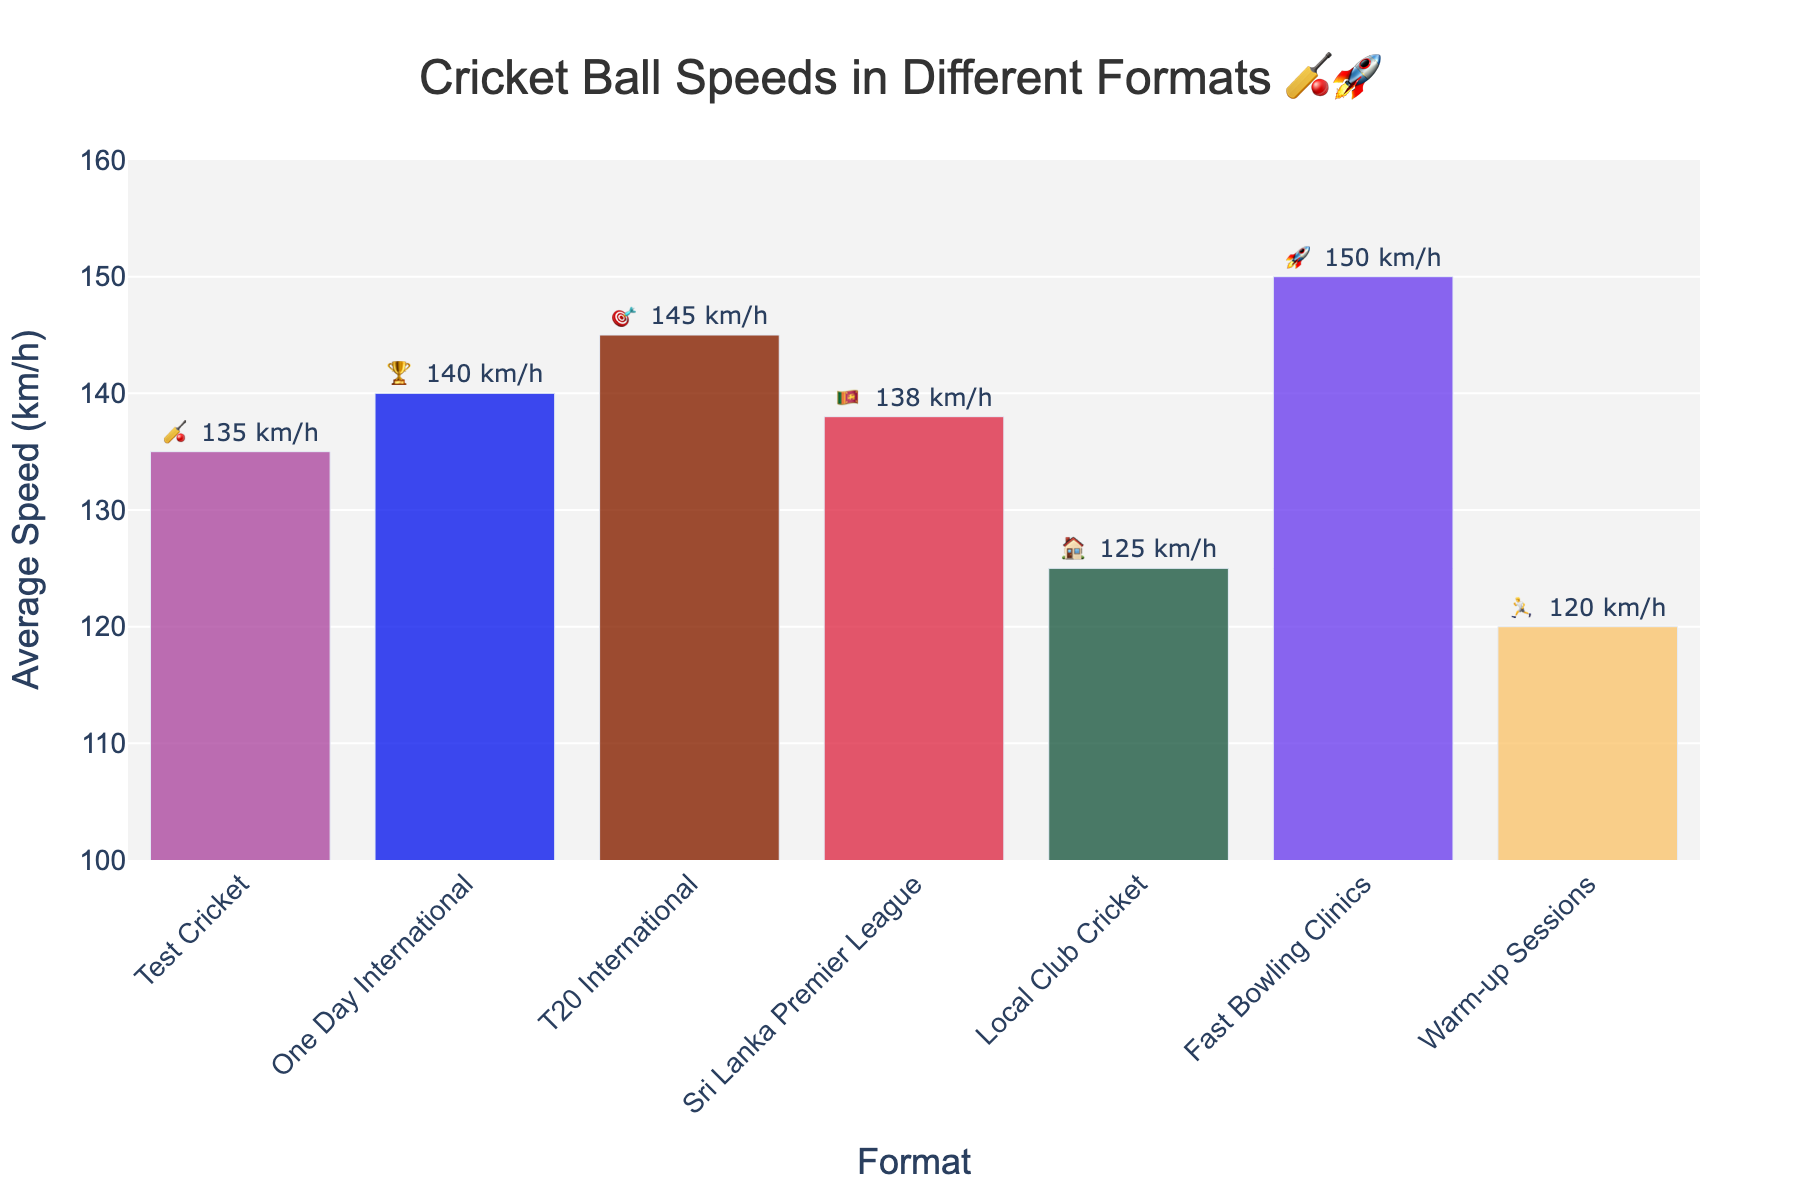what is the title of the figure? The title is found at the top of the figure and is designed to give a quick summary of the content of the chart.
Answer: Cricket Ball Speeds in Different Formats 🏏🚀 which format has the highest average speed? Look for the highest bar in the figure, as the bar's height corresponds to the speed.
Answer: Fast Bowling Clinics what is the average speed for T20 International? Identify the bar labeled T20 International and read its corresponding value.
Answer: 145 km/h how much faster is Sri Lanka Premier League compared to Local Club Cricket? Subtract the speed of Local Club Cricket from that of the Sri Lanka Premier League.
Answer: 13 km/h which format has the lowest average speed, and what is that speed? Identify the shortest bar in the figure and note its label and height.
Answer: Warm-up Sessions, 120 km/h how many formats have an average speed greater than 140 km/h? Count the number of bars that have values higher than 140 km/h.
Answer: 2 what is the difference in average speed between One Day International and Test Cricket? Subtract the speed of Test Cricket from that of One Day International.
Answer: 5 km/h are there more formats with speeds above or below 130 km/h? Count the number of bars above and below 130 km/h and compare.
Answer: More above 130 km/h in which formats is the average speed mentioned with an emoji? Besides the speeds, see if there's an emoji displayed next to some text in the bar.
Answer: Test Cricket: 🏏 135 km/h, One Day International: 🏆 140 km/h, T20 International: 🎯 145 km/h, Sri Lanka Premier League: 🇱🇰 138 km/h, Local Club Cricket: 🏠 125 km/h, Fast Bowling Clinics: 🚀 150 km/h, Warm-up Sessions: 🏃 120 km/h what's the range of average speeds in all formats? Find the difference between the highest and lowest average speeds.
Answer: 30 km/h 